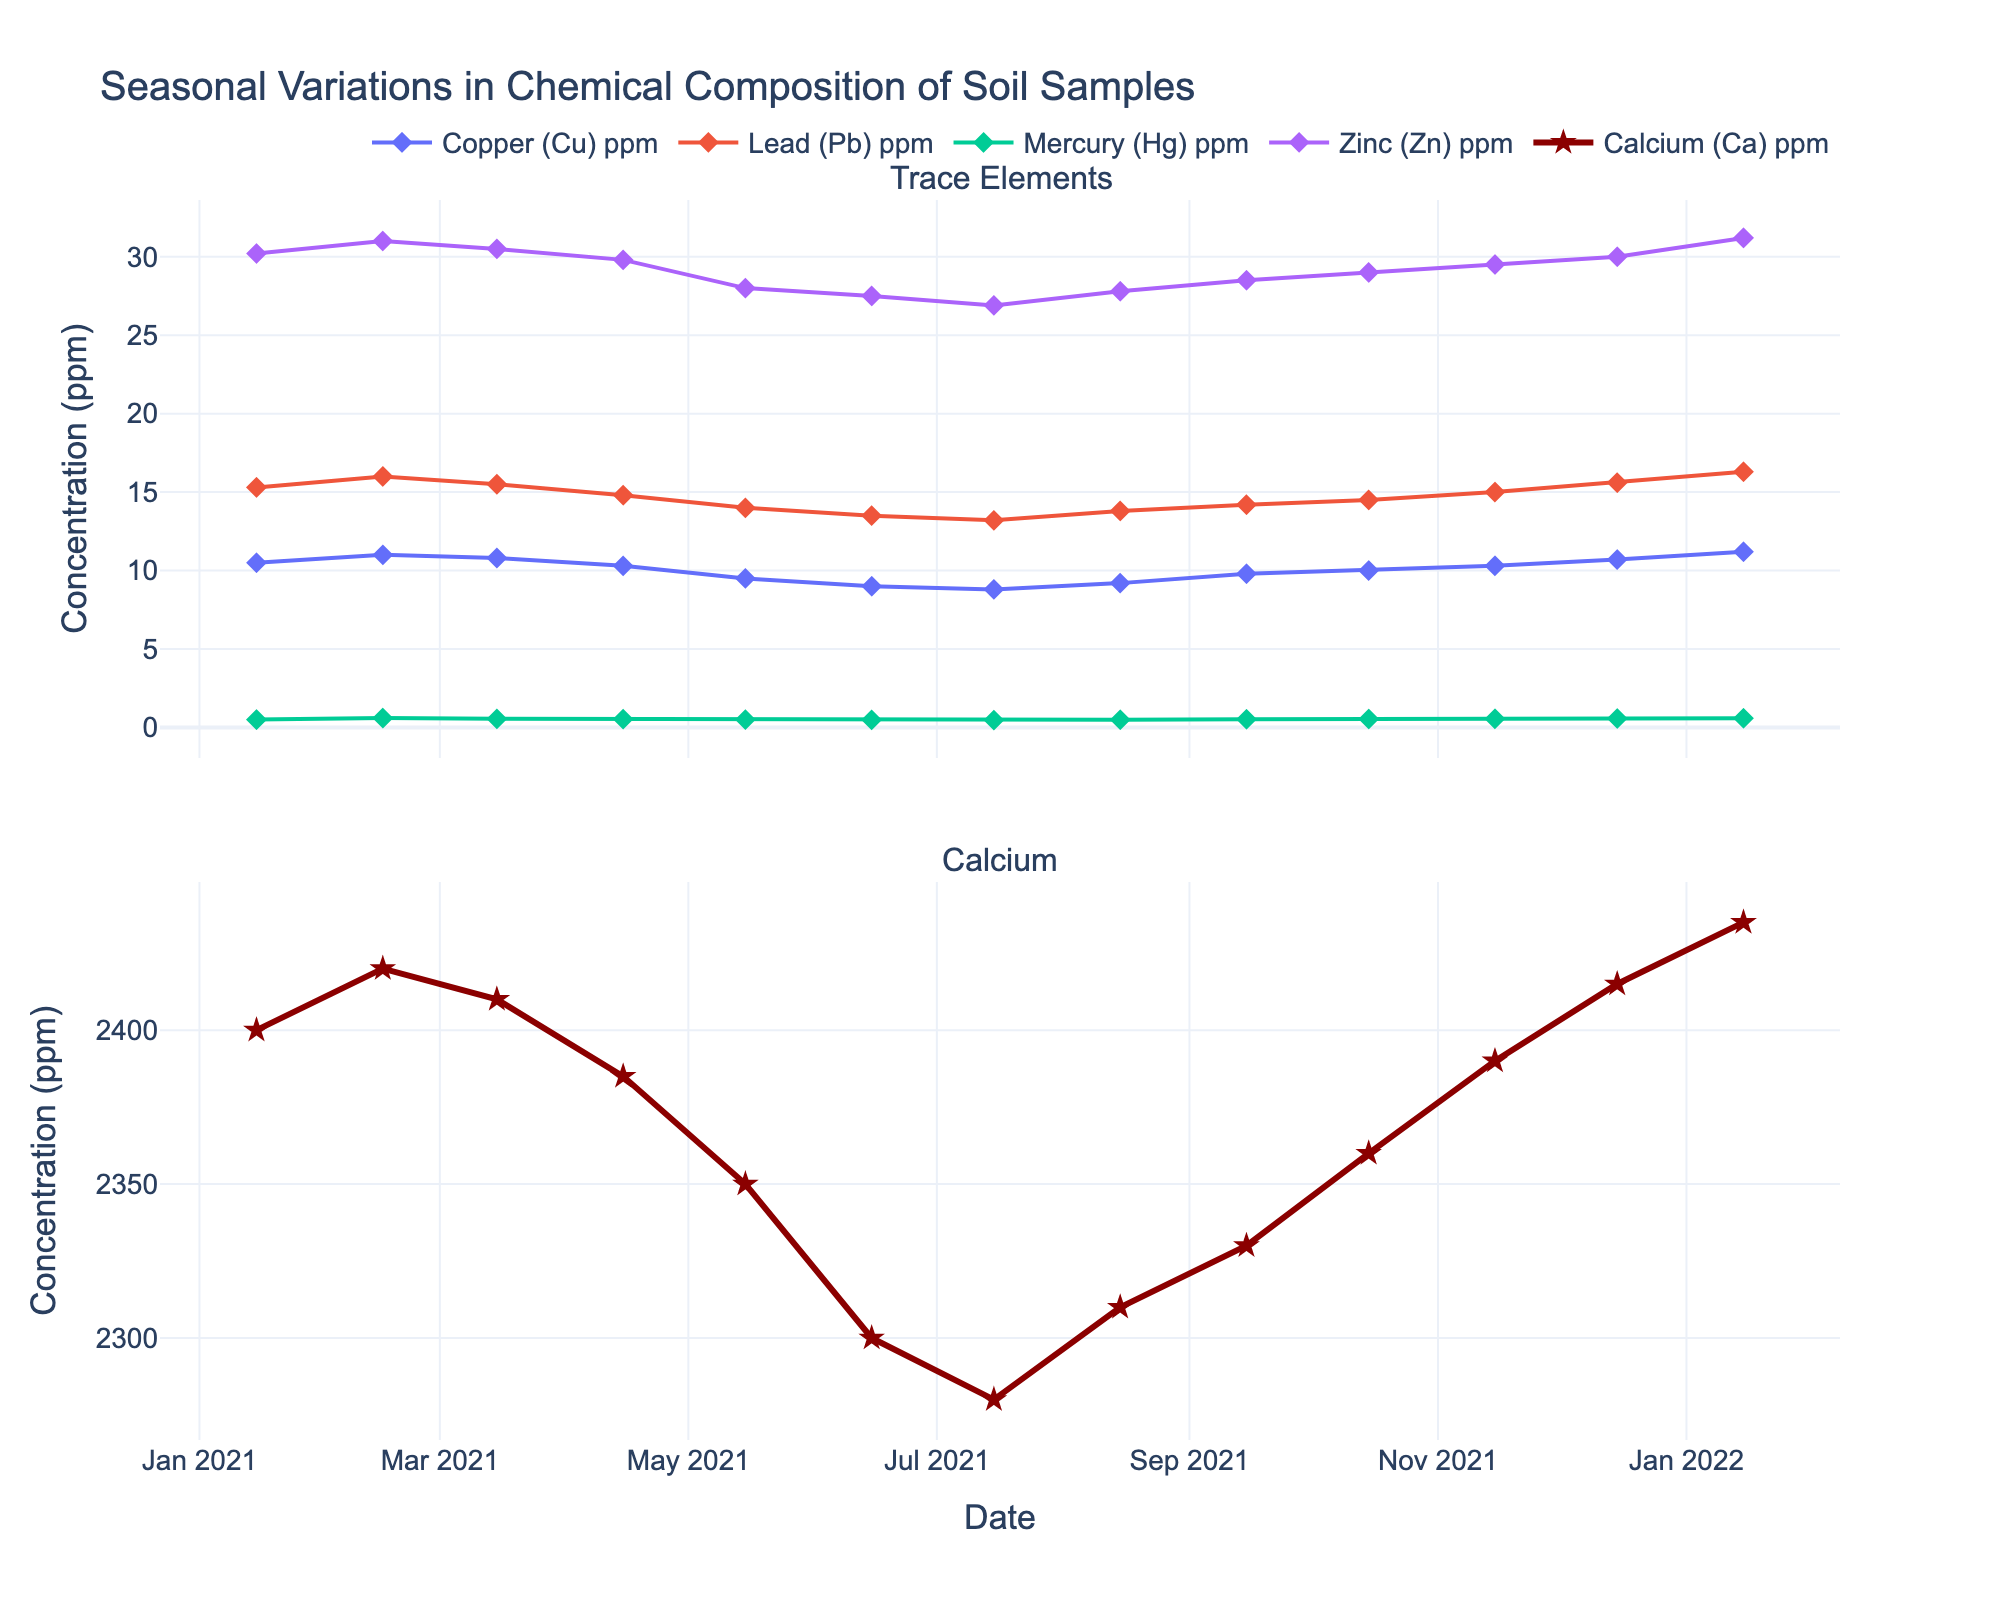What's the title of the plot? The title is usually displayed at the top of the plot. In this figure, the title describes the data it represents.
Answer: Seasonal Variations in Chemical Composition of Soil Samples How many distinct lines are in the first subplot? The first subplot includes lines for each trace element. By visually counting, we can observe there are 4 lines, each representing a different element.
Answer: 4 What element shows the highest concentration in January 2022? Looking at the data points for January 2022 (near the end of the x-axis), we compare the lines. The element with the highest corresponding y-value (concentration) is the one we seek.
Answer: Calcium (Ca) What is the trend of Zinc (Zn) concentration from January 2021 to June 2021? Track the Zinc (Zn) line specifically from the start of the plot (January 2021) to mid-year (June 2021). Observe if it increases, decreases, or stays constant.
Answer: Decreasing Which trace element shows an increase in concentration from July 2021 to January 2022? Checking the lines for each trace element between July 2021 and January 2022, the lines that show an upward trend indicate an increase.
Answer: Copper (Cu) What's the difference in concentration between Lead (Pb) and Mercury (Hg) in April 2021? Identify the data points for both Lead (Pb) and Mercury (Hg) in April 2021 and subtract the value of Mercury (Hg) from Lead (Pb).
Answer: 14.8 - 0.53 = 14.27 Which element has the most stable concentration throughout the year? Look for the line with the smallest fluctuations (least variation) from the start to the end of the plot. This indicates stability.
Answer: Mercury (Hg) How does Calcium (Ca) concentration change over the seasons? Track the Calcium (Ca) line in the second subplot for seasonal changes from the beginning to the end of the year, noting any upward or downward trends.
Answer: It decreases slightly during summer and increases again towards winter 